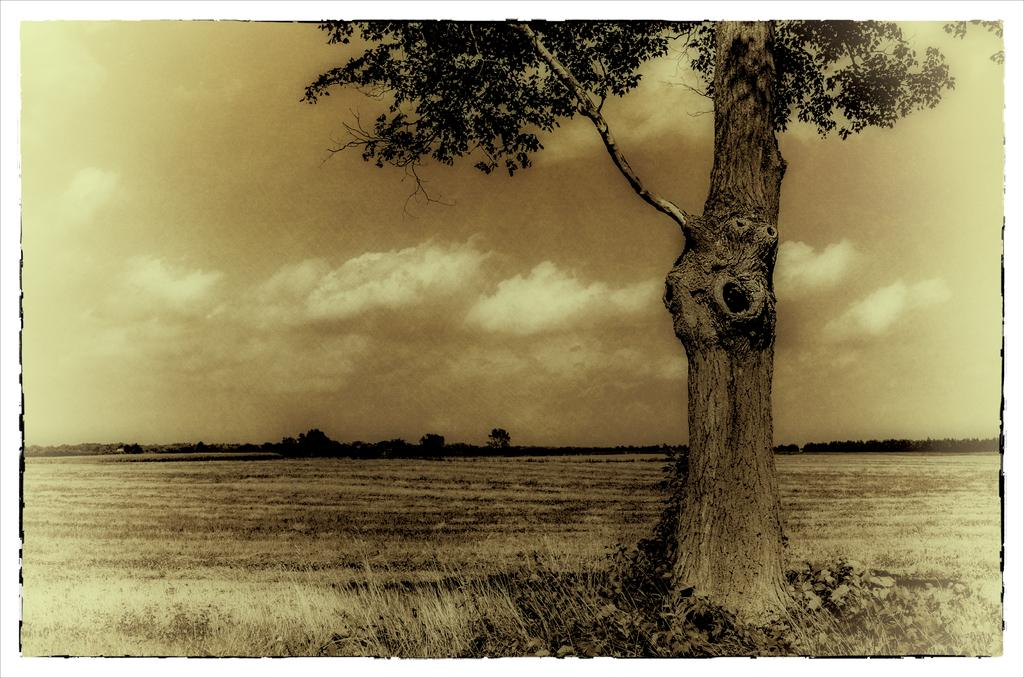What is the main subject of the image? The main subject of the image is a tree field. What can be seen in the background of the image? There are trees and the sky visible in the background of the image. How many pies are being baked by the parent in the image? There is no parent or pies present in the image; it features a tree field with trees and the sky in the background. 